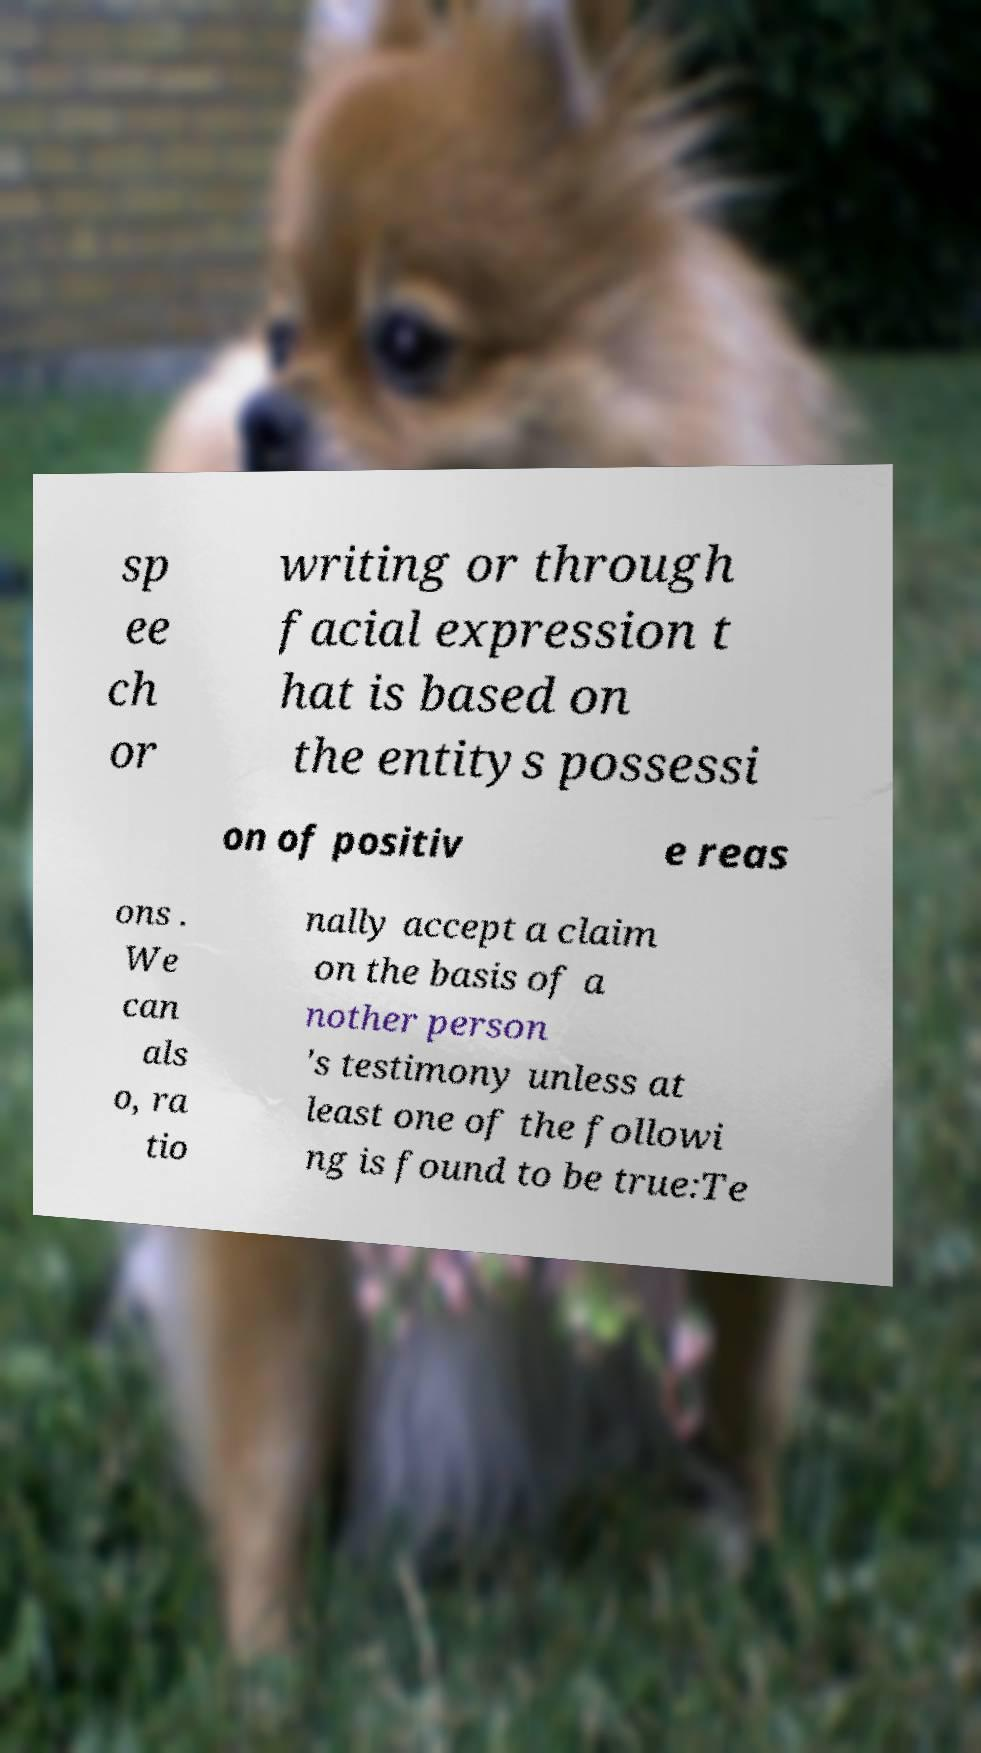Please identify and transcribe the text found in this image. sp ee ch or writing or through facial expression t hat is based on the entitys possessi on of positiv e reas ons . We can als o, ra tio nally accept a claim on the basis of a nother person 's testimony unless at least one of the followi ng is found to be true:Te 